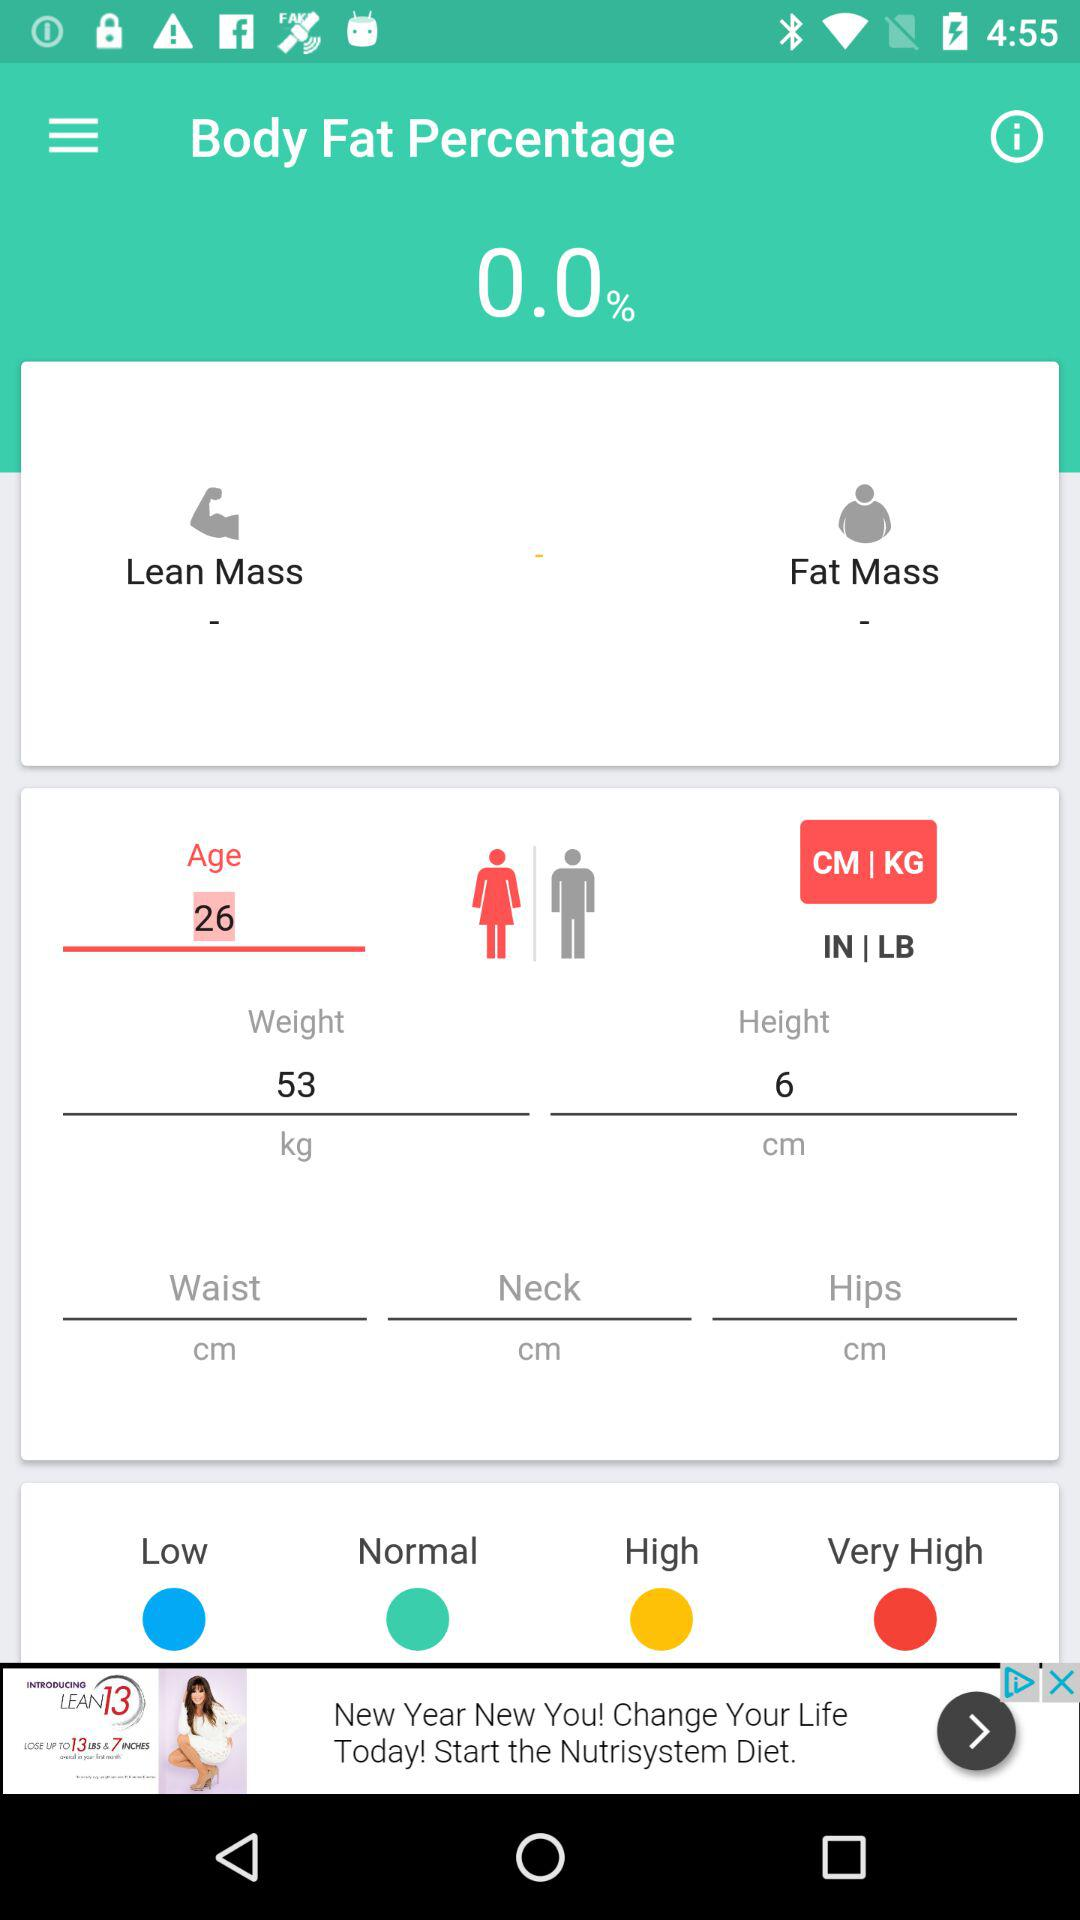What is the age of the girl? The age of the girl is 26. 